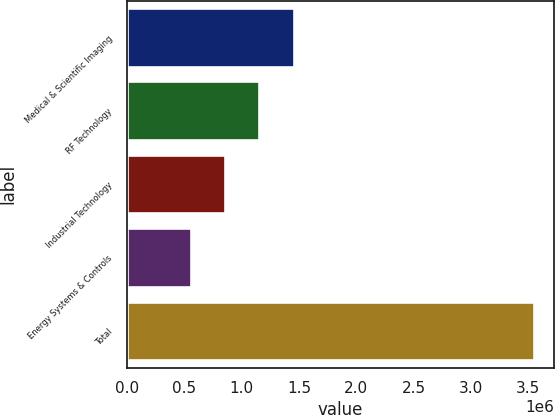Convert chart to OTSL. <chart><loc_0><loc_0><loc_500><loc_500><bar_chart><fcel>Medical & Scientific Imaging<fcel>RF Technology<fcel>Industrial Technology<fcel>Energy Systems & Controls<fcel>Total<nl><fcel>1.45326e+06<fcel>1.15406e+06<fcel>854867<fcel>555672<fcel>3.54762e+06<nl></chart> 